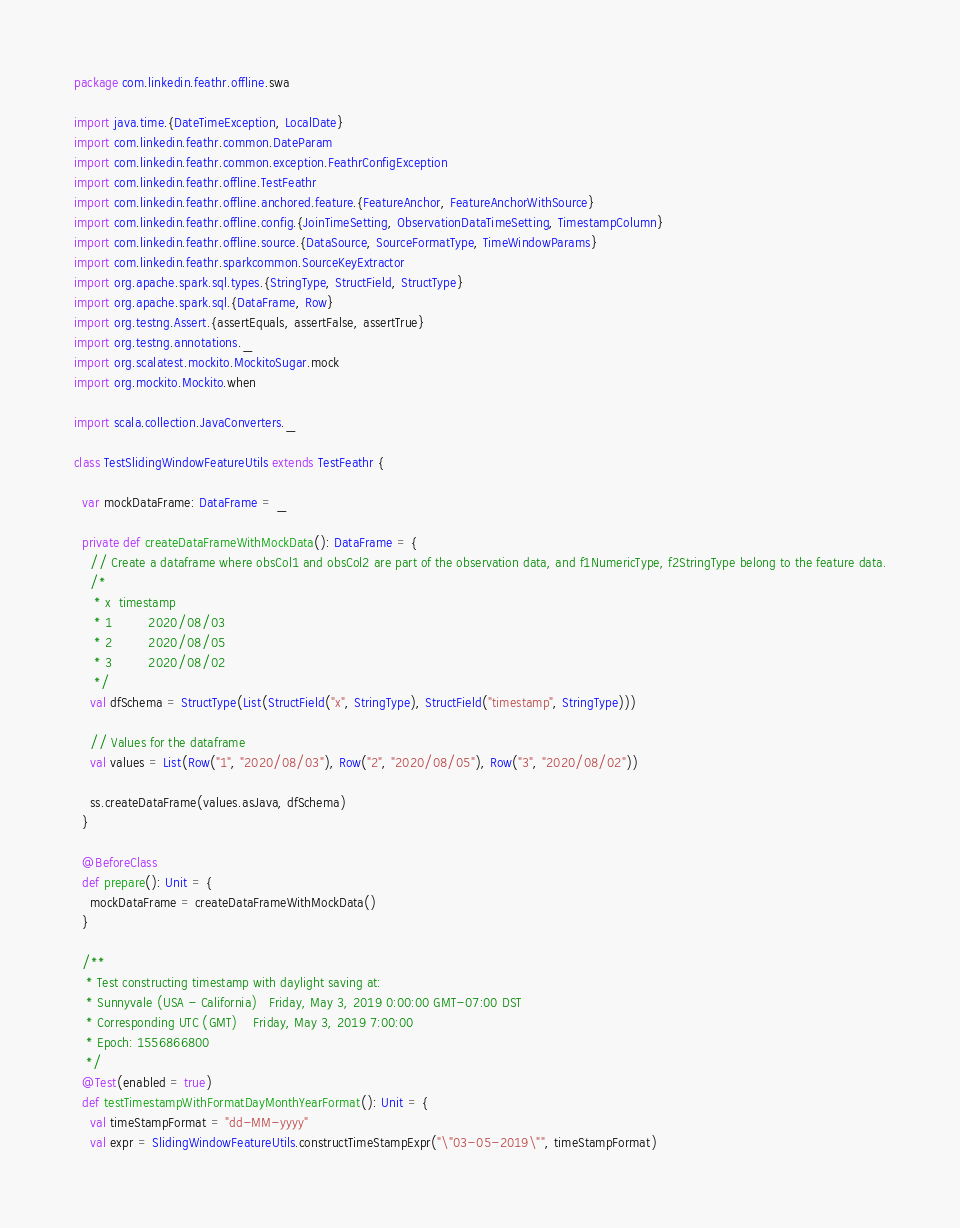<code> <loc_0><loc_0><loc_500><loc_500><_Scala_>package com.linkedin.feathr.offline.swa

import java.time.{DateTimeException, LocalDate}
import com.linkedin.feathr.common.DateParam
import com.linkedin.feathr.common.exception.FeathrConfigException
import com.linkedin.feathr.offline.TestFeathr
import com.linkedin.feathr.offline.anchored.feature.{FeatureAnchor, FeatureAnchorWithSource}
import com.linkedin.feathr.offline.config.{JoinTimeSetting, ObservationDataTimeSetting, TimestampColumn}
import com.linkedin.feathr.offline.source.{DataSource, SourceFormatType, TimeWindowParams}
import com.linkedin.feathr.sparkcommon.SourceKeyExtractor
import org.apache.spark.sql.types.{StringType, StructField, StructType}
import org.apache.spark.sql.{DataFrame, Row}
import org.testng.Assert.{assertEquals, assertFalse, assertTrue}
import org.testng.annotations._
import org.scalatest.mockito.MockitoSugar.mock
import org.mockito.Mockito.when

import scala.collection.JavaConverters._

class TestSlidingWindowFeatureUtils extends TestFeathr {

  var mockDataFrame: DataFrame = _

  private def createDataFrameWithMockData(): DataFrame = {
    // Create a dataframe where obsCol1 and obsCol2 are part of the observation data, and f1NumericType, f2StringType belong to the feature data.
    /*
     * x  timestamp
     * 1         2020/08/03
     * 2         2020/08/05
     * 3         2020/08/02
     */
    val dfSchema = StructType(List(StructField("x", StringType), StructField("timestamp", StringType)))

    // Values for the dataframe
    val values = List(Row("1", "2020/08/03"), Row("2", "2020/08/05"), Row("3", "2020/08/02"))

    ss.createDataFrame(values.asJava, dfSchema)
  }

  @BeforeClass
  def prepare(): Unit = {
    mockDataFrame = createDataFrameWithMockData()
  }

  /**
   * Test constructing timestamp with daylight saving at:
   * Sunnyvale (USA - California)	Friday, May 3, 2019 0:00:00 GMT-07:00 DST
   * Corresponding UTC (GMT)	Friday, May 3, 2019 7:00:00
   * Epoch: 1556866800
   */
  @Test(enabled = true)
  def testTimestampWithFormatDayMonthYearFormat(): Unit = {
    val timeStampFormat = "dd-MM-yyyy"
    val expr = SlidingWindowFeatureUtils.constructTimeStampExpr("\"03-05-2019\"", timeStampFormat)
</code> 